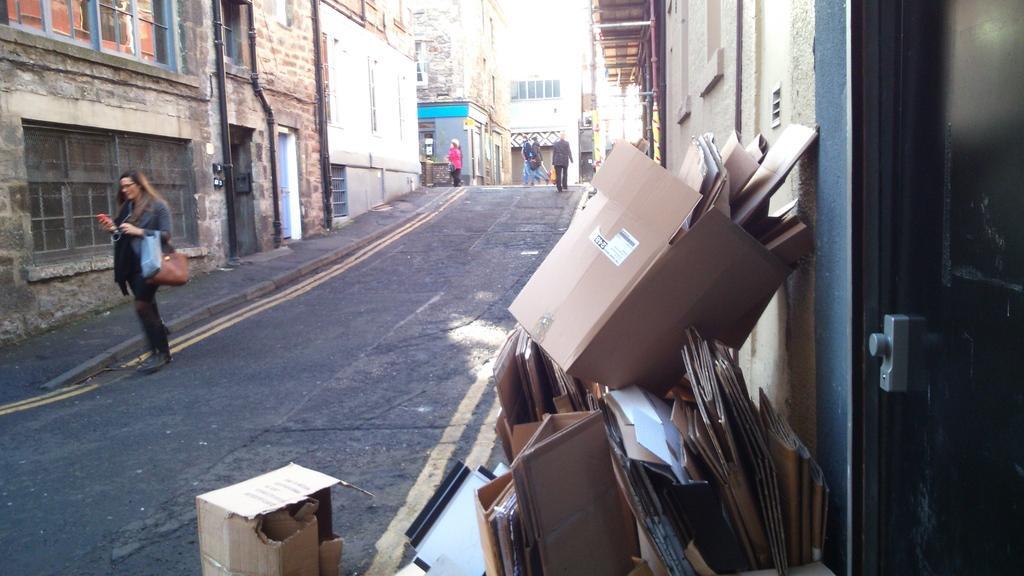How would you summarize this image in a sentence or two? In the picture I can see people standing on the road. I can also see buildings, pipes attached to the walls of buildings, yellow lines on the road, cardboard boxes and some other object on the ground. 